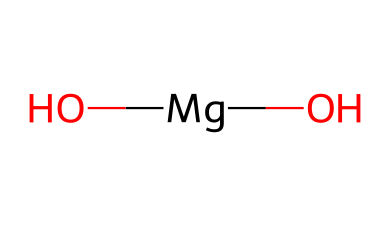What is the chemical name for the structure represented? The chemical structure [Mg](O)(O) represents magnesium hydroxide. The magnesium (Mg) is bonded to two hydroxide (OH) groups, which defines its chemical identity.
Answer: magnesium hydroxide How many oxygen atoms are present in this compound? In the structure, there are two hydroxide groups (O). Each hydroxide contributes one oxygen atom, so there are two in total.
Answer: 2 What type of chemical is magnesium hydroxide? Magnesium hydroxide is classified as a base due to the presence of hydroxide ions, which are characteristic of basic compounds.
Answer: base What is the main use of magnesium hydroxide in indigenous practices? Magnesium hydroxide is commonly used in indigenous medicinal practices for alleviating digestive issues such as acid reflux and indigestion.
Answer: digestive issues What ions are present in magnesium hydroxide? The compound contains magnesium ions (Mg²⁺) and hydroxide ions (OH⁻), indicating that it can act in a basic capacity by providing hydroxide ions in solution.
Answer: Mg²⁺ and OH⁻ How might the structure of magnesium hydroxide influence its solubility? The presence of hydroxide groups can influence the solubility of magnesium hydroxide in water, as bases tend to be more soluble in acidic solutions due to interactions with protons.
Answer: influences solubility What does the presence of magnesium indicate about the compound's properties? Magnesium is an alkaline earth metal, which suggests that the compound may have mild basicity and can interact with acids in neutralization reactions, indicating its use in gastrointestinal relief.
Answer: mild basicity 